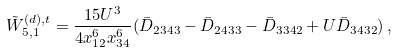Convert formula to latex. <formula><loc_0><loc_0><loc_500><loc_500>\tilde { W } ^ { ( d ) , t } _ { 5 , 1 } = \frac { 1 5 U ^ { 3 } } { 4 x _ { 1 2 } ^ { 6 } x _ { 3 4 } ^ { 6 } } ( \bar { D } _ { 2 3 4 3 } - \bar { D } _ { 2 4 3 3 } - \bar { D } _ { 3 3 4 2 } + U \bar { D } _ { 3 4 3 2 } ) \, ,</formula> 